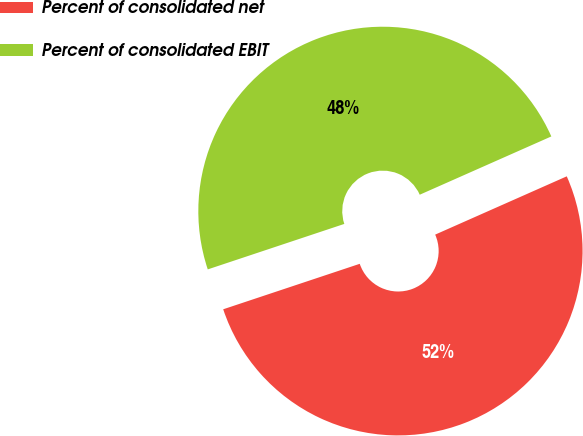Convert chart to OTSL. <chart><loc_0><loc_0><loc_500><loc_500><pie_chart><fcel>Percent of consolidated net<fcel>Percent of consolidated EBIT<nl><fcel>51.52%<fcel>48.48%<nl></chart> 